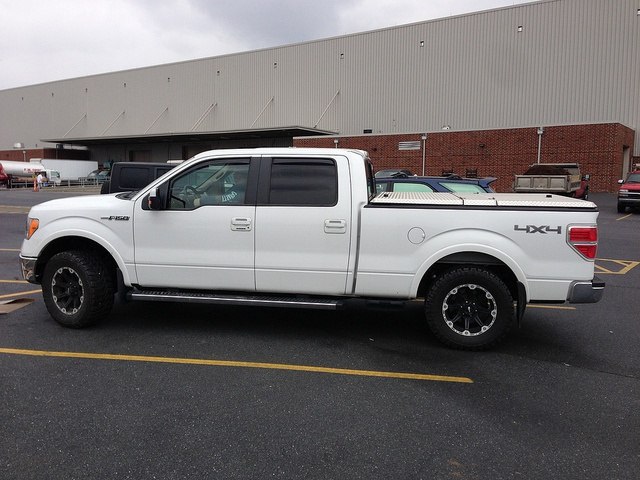Describe the objects in this image and their specific colors. I can see truck in white, black, lightgray, darkgray, and gray tones, truck in white, black, gray, and maroon tones, car in white, black, and gray tones, car in white, gray, black, turquoise, and darkgray tones, and people in white, purple, black, and gray tones in this image. 